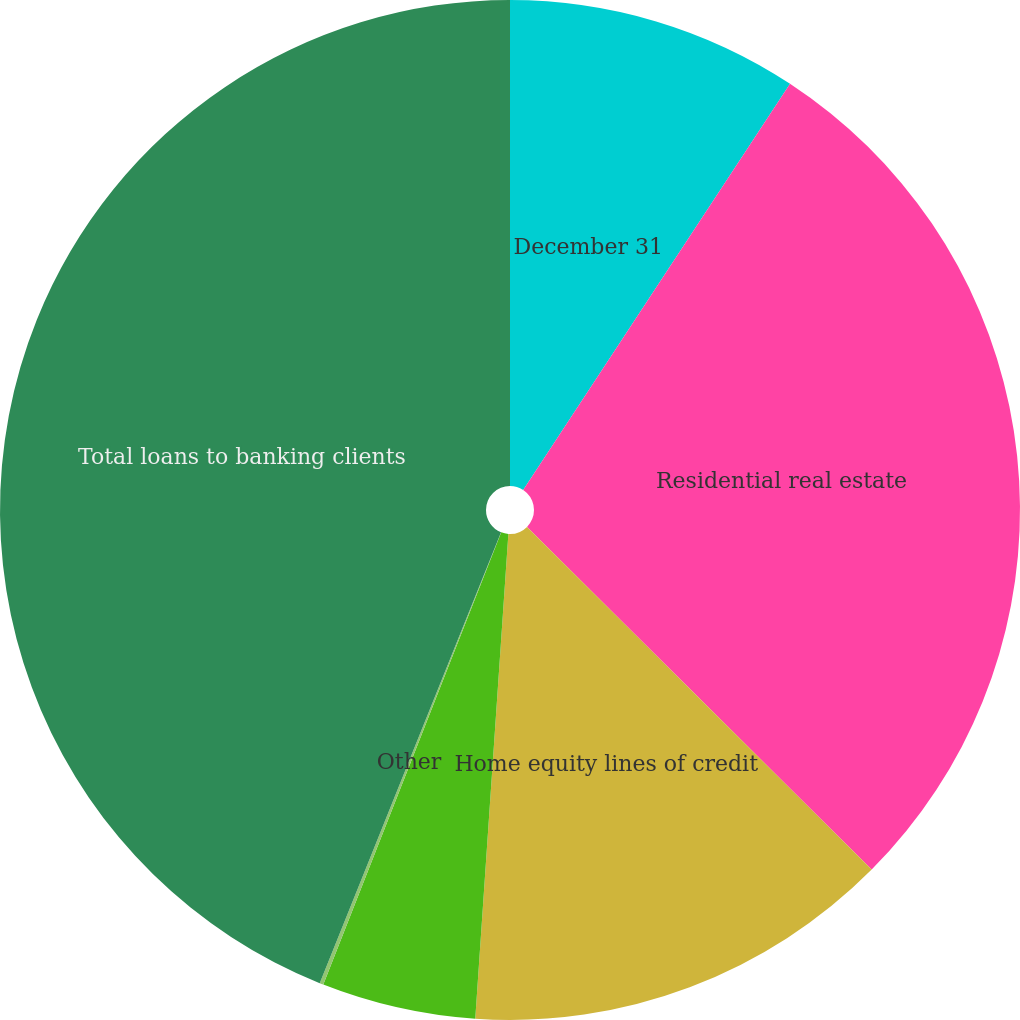Convert chart. <chart><loc_0><loc_0><loc_500><loc_500><pie_chart><fcel>December 31<fcel>Residential real estate<fcel>Home equity lines of credit<fcel>Personal loans secured by<fcel>Other<fcel>Total loans to banking clients<nl><fcel>9.25%<fcel>28.2%<fcel>13.63%<fcel>4.88%<fcel>0.12%<fcel>43.91%<nl></chart> 